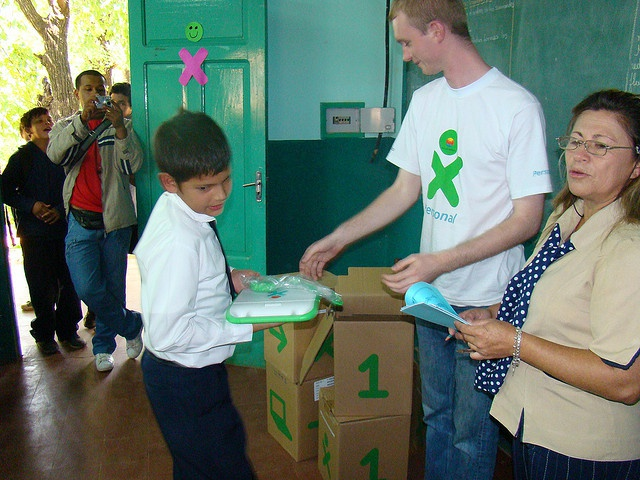Describe the objects in this image and their specific colors. I can see people in lightyellow, lightgray, darkgray, blue, and navy tones, people in lightyellow, darkgray, tan, and black tones, people in lightyellow, black, lightblue, and gray tones, people in lightyellow, black, gray, maroon, and blue tones, and people in lightyellow, black, blue, maroon, and olive tones in this image. 